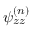<formula> <loc_0><loc_0><loc_500><loc_500>\psi _ { z z } ^ { ( n ) }</formula> 